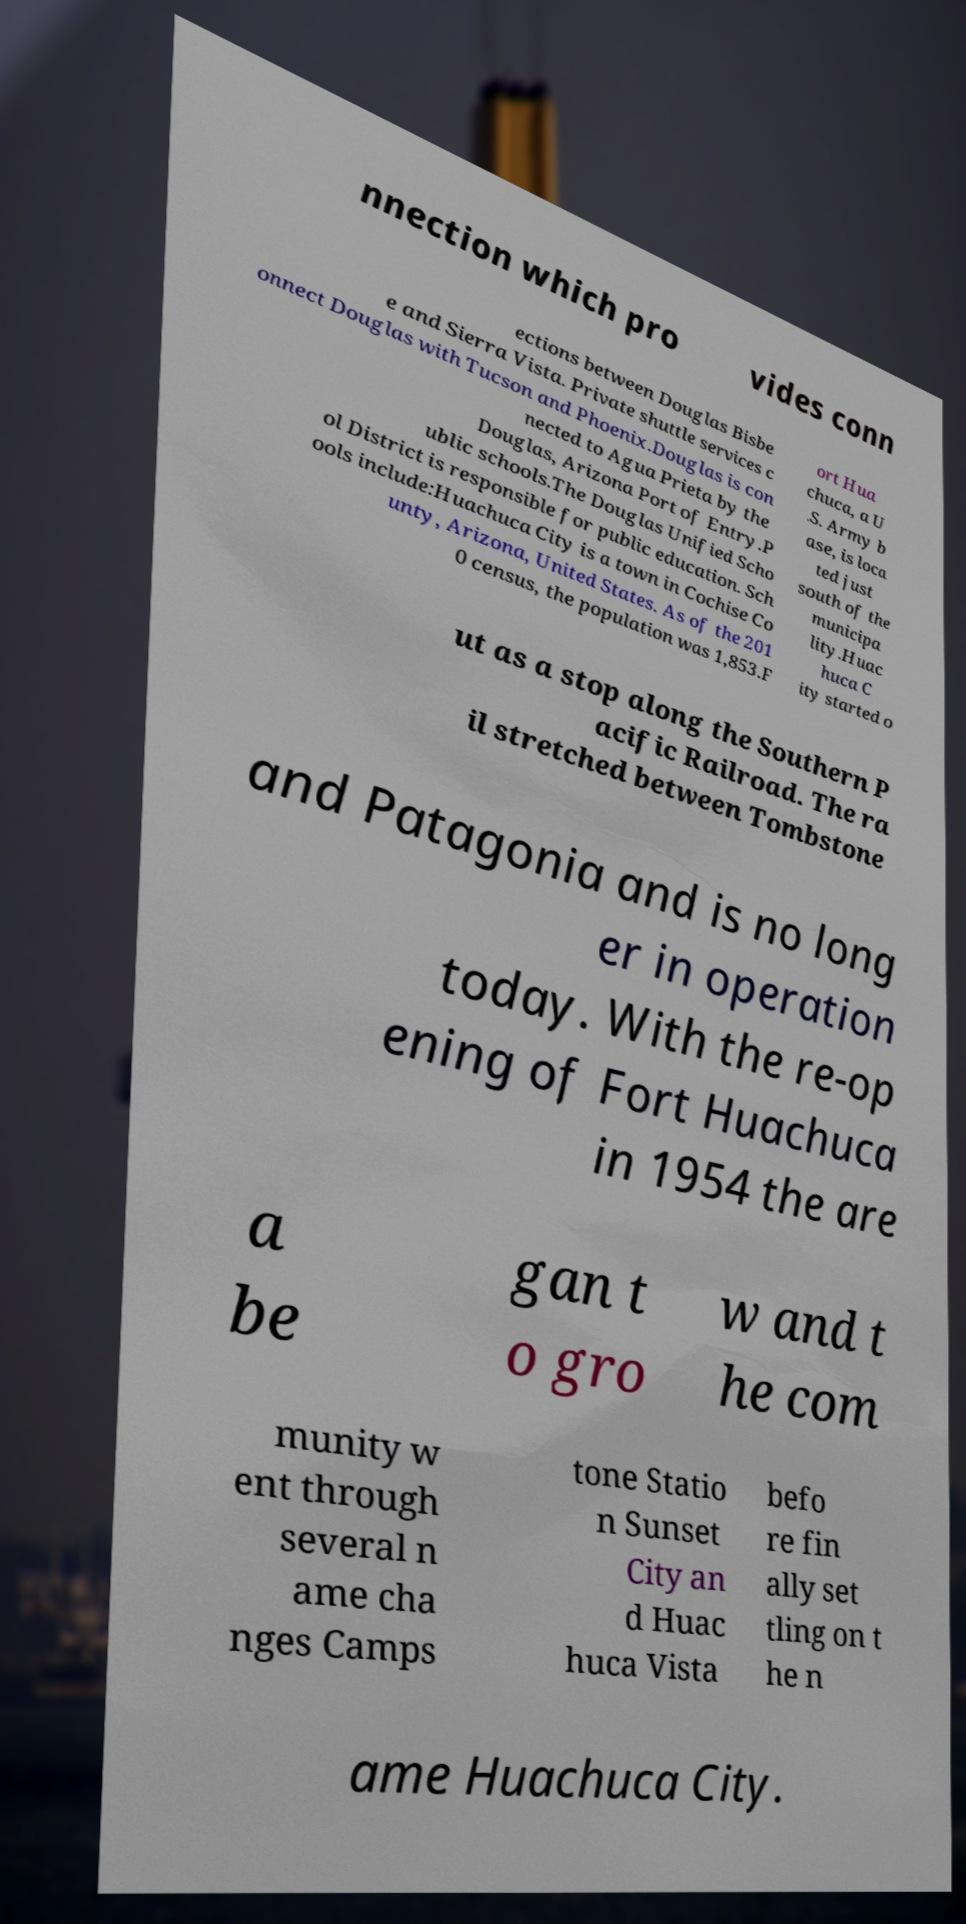There's text embedded in this image that I need extracted. Can you transcribe it verbatim? nnection which pro vides conn ections between Douglas Bisbe e and Sierra Vista. Private shuttle services c onnect Douglas with Tucson and Phoenix.Douglas is con nected to Agua Prieta by the Douglas, Arizona Port of Entry.P ublic schools.The Douglas Unified Scho ol District is responsible for public education. Sch ools include:Huachuca City is a town in Cochise Co unty, Arizona, United States. As of the 201 0 census, the population was 1,853.F ort Hua chuca, a U .S. Army b ase, is loca ted just south of the municipa lity.Huac huca C ity started o ut as a stop along the Southern P acific Railroad. The ra il stretched between Tombstone and Patagonia and is no long er in operation today. With the re-op ening of Fort Huachuca in 1954 the are a be gan t o gro w and t he com munity w ent through several n ame cha nges Camps tone Statio n Sunset City an d Huac huca Vista befo re fin ally set tling on t he n ame Huachuca City. 